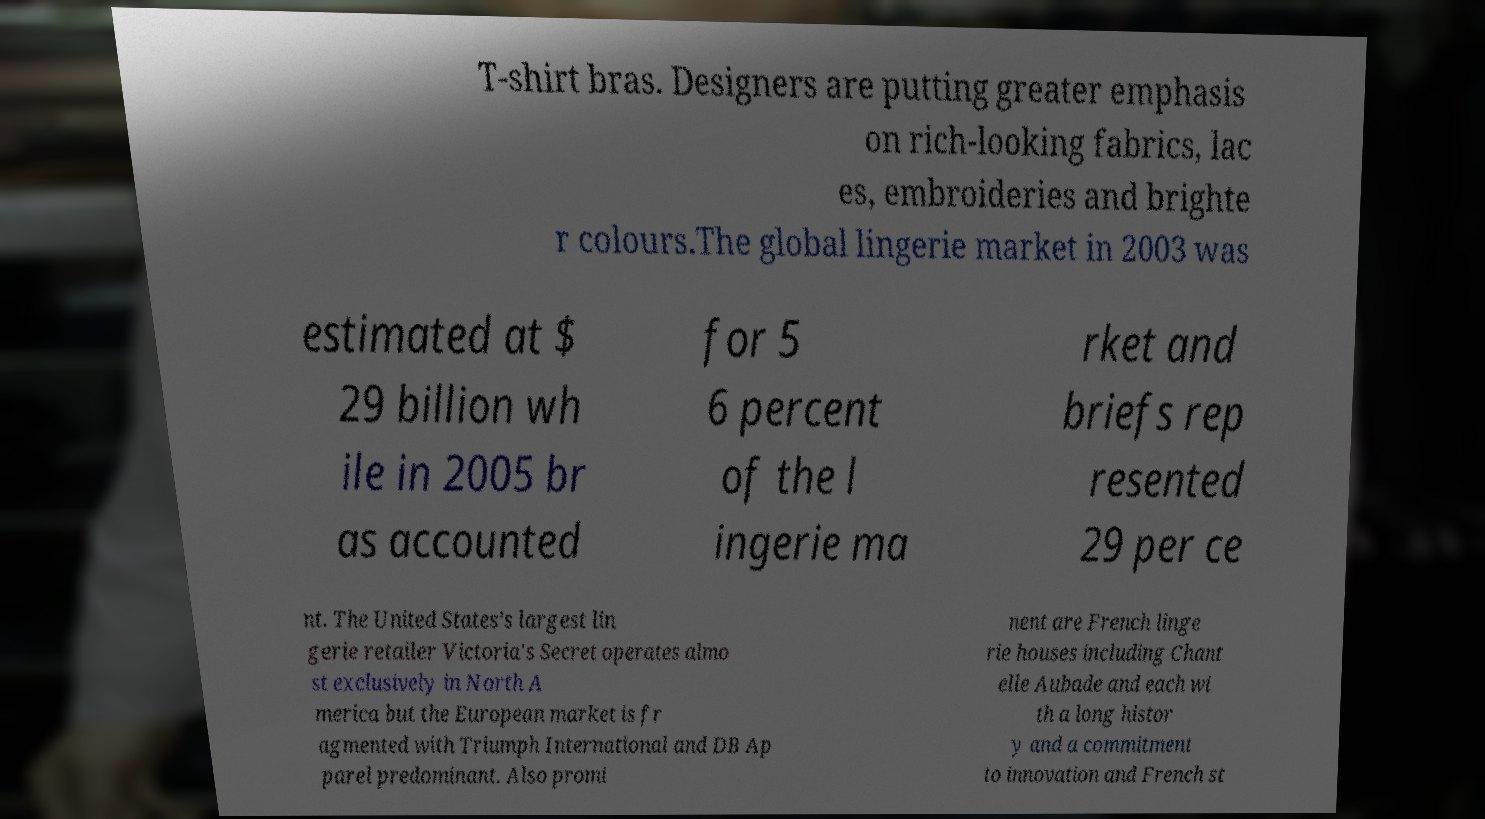Can you accurately transcribe the text from the provided image for me? T-shirt bras. Designers are putting greater emphasis on rich-looking fabrics, lac es, embroideries and brighte r colours.The global lingerie market in 2003 was estimated at $ 29 billion wh ile in 2005 br as accounted for 5 6 percent of the l ingerie ma rket and briefs rep resented 29 per ce nt. The United States’s largest lin gerie retailer Victoria's Secret operates almo st exclusively in North A merica but the European market is fr agmented with Triumph International and DB Ap parel predominant. Also promi nent are French linge rie houses including Chant elle Aubade and each wi th a long histor y and a commitment to innovation and French st 